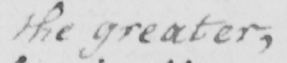What is written in this line of handwriting? the greater , 